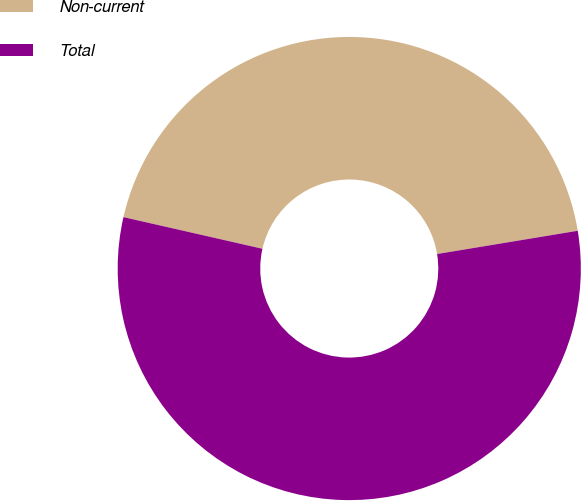Convert chart. <chart><loc_0><loc_0><loc_500><loc_500><pie_chart><fcel>Non-current<fcel>Total<nl><fcel>43.83%<fcel>56.17%<nl></chart> 